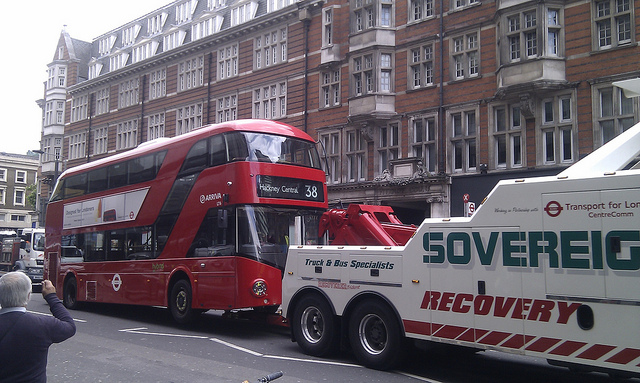Please identify all text content in this image. SOVEREIG RECOVERY Track BUS Speciallists Lof for Transport 38 